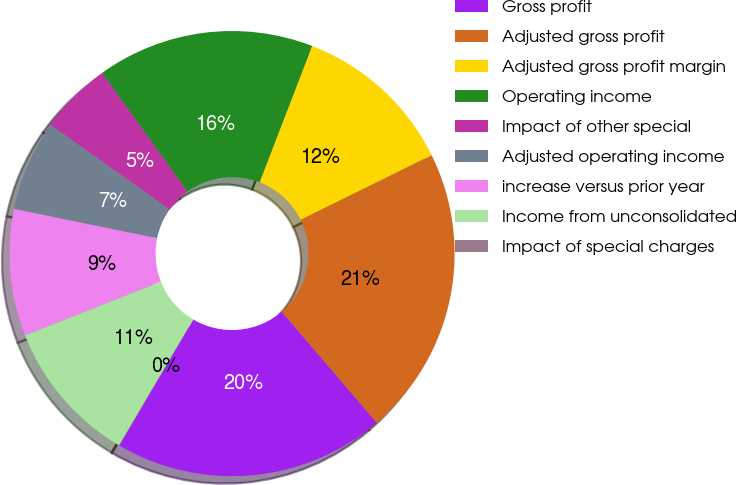Convert chart to OTSL. <chart><loc_0><loc_0><loc_500><loc_500><pie_chart><fcel>Gross profit<fcel>Adjusted gross profit<fcel>Adjusted gross profit margin<fcel>Operating income<fcel>Impact of other special<fcel>Adjusted operating income<fcel>increase versus prior year<fcel>Income from unconsolidated<fcel>Impact of special charges<nl><fcel>19.72%<fcel>21.03%<fcel>11.84%<fcel>15.78%<fcel>5.27%<fcel>6.59%<fcel>9.21%<fcel>10.53%<fcel>0.02%<nl></chart> 